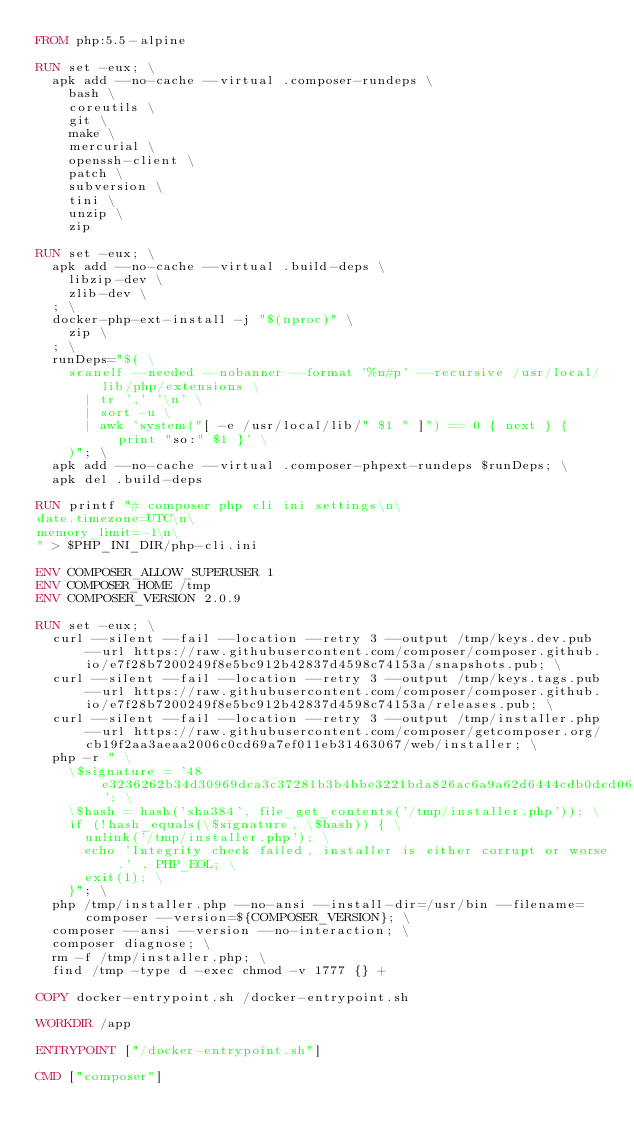Convert code to text. <code><loc_0><loc_0><loc_500><loc_500><_Dockerfile_>FROM php:5.5-alpine

RUN set -eux; \
  apk add --no-cache --virtual .composer-rundeps \
    bash \
    coreutils \
    git \
    make \
    mercurial \
    openssh-client \
    patch \
    subversion \
    tini \
    unzip \
    zip

RUN set -eux; \
  apk add --no-cache --virtual .build-deps \
    libzip-dev \
    zlib-dev \
  ; \
  docker-php-ext-install -j "$(nproc)" \
    zip \
  ; \
  runDeps="$( \
    scanelf --needed --nobanner --format '%n#p' --recursive /usr/local/lib/php/extensions \
      | tr ',' '\n' \
      | sort -u \
      | awk 'system("[ -e /usr/local/lib/" $1 " ]") == 0 { next } { print "so:" $1 }' \
    )"; \
  apk add --no-cache --virtual .composer-phpext-rundeps $runDeps; \
  apk del .build-deps

RUN printf "# composer php cli ini settings\n\
date.timezone=UTC\n\
memory_limit=-1\n\
" > $PHP_INI_DIR/php-cli.ini

ENV COMPOSER_ALLOW_SUPERUSER 1
ENV COMPOSER_HOME /tmp
ENV COMPOSER_VERSION 2.0.9

RUN set -eux; \
  curl --silent --fail --location --retry 3 --output /tmp/keys.dev.pub --url https://raw.githubusercontent.com/composer/composer.github.io/e7f28b7200249f8e5bc912b42837d4598c74153a/snapshots.pub; \
  curl --silent --fail --location --retry 3 --output /tmp/keys.tags.pub --url https://raw.githubusercontent.com/composer/composer.github.io/e7f28b7200249f8e5bc912b42837d4598c74153a/releases.pub; \
  curl --silent --fail --location --retry 3 --output /tmp/installer.php --url https://raw.githubusercontent.com/composer/getcomposer.org/cb19f2aa3aeaa2006c0cd69a7ef011eb31463067/web/installer; \
  php -r " \
    \$signature = '48e3236262b34d30969dca3c37281b3b4bbe3221bda826ac6a9a62d6444cdb0dcd0615698a5cbe587c3f0fe57a54d8f5'; \
    \$hash = hash('sha384', file_get_contents('/tmp/installer.php')); \
    if (!hash_equals(\$signature, \$hash)) { \
      unlink('/tmp/installer.php'); \
      echo 'Integrity check failed, installer is either corrupt or worse.' . PHP_EOL; \
      exit(1); \
    }"; \
  php /tmp/installer.php --no-ansi --install-dir=/usr/bin --filename=composer --version=${COMPOSER_VERSION}; \
  composer --ansi --version --no-interaction; \
  composer diagnose; \
  rm -f /tmp/installer.php; \
  find /tmp -type d -exec chmod -v 1777 {} +

COPY docker-entrypoint.sh /docker-entrypoint.sh

WORKDIR /app

ENTRYPOINT ["/docker-entrypoint.sh"]

CMD ["composer"]
</code> 